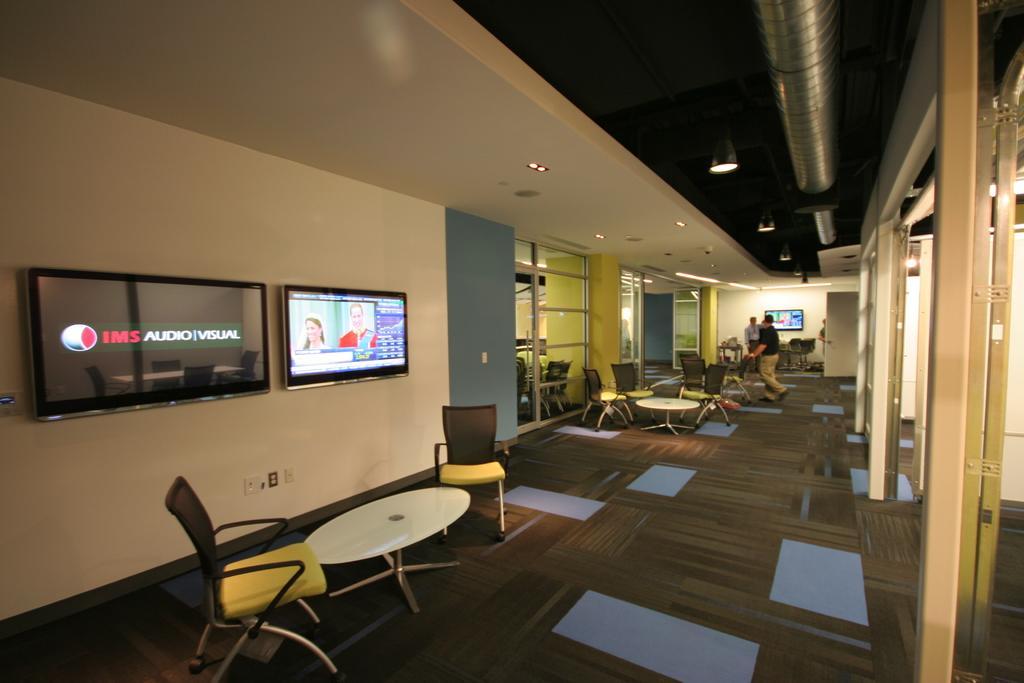Can you describe this image briefly? In this image, I can see two television screens, which are attached to a wall. These are the tables and chairs. I can see few people standing. These are the glass doors. I can see the ceiling lights, which are attached to the ceiling. This looks like a pipe. In the background, I can see another television screen, which is attached to a wall. This is a floor. 